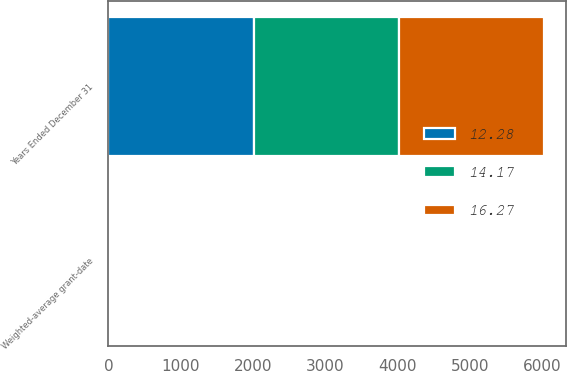<chart> <loc_0><loc_0><loc_500><loc_500><stacked_bar_chart><ecel><fcel>Years Ended December 31<fcel>Weighted-average grant-date<nl><fcel>12.28<fcel>2012<fcel>12.32<nl><fcel>14.17<fcel>2011<fcel>13.89<nl><fcel>16.27<fcel>2010<fcel>16.22<nl></chart> 